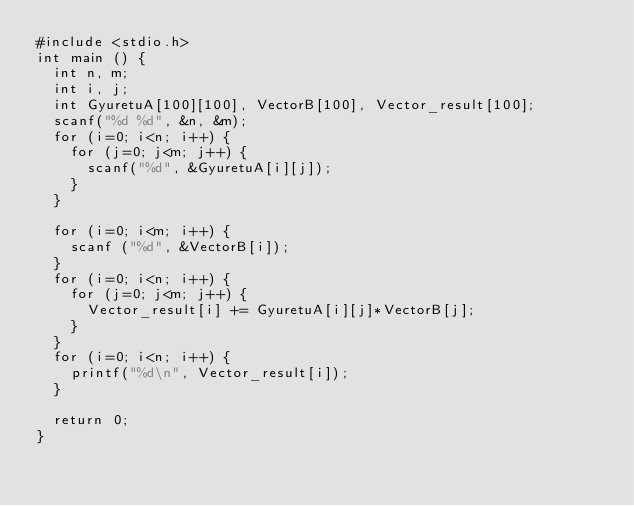<code> <loc_0><loc_0><loc_500><loc_500><_C_>#include <stdio.h>
int main () {
  int n, m;
  int i, j;
  int GyuretuA[100][100], VectorB[100], Vector_result[100];
  scanf("%d %d", &n, &m);
  for (i=0; i<n; i++) {
    for (j=0; j<m; j++) {
      scanf("%d", &GyuretuA[i][j]);
    }
  }

  for (i=0; i<m; i++) {
    scanf ("%d", &VectorB[i]);
  }
  for (i=0; i<n; i++) {
    for (j=0; j<m; j++) {
      Vector_result[i] += GyuretuA[i][j]*VectorB[j];
    }
  }
  for (i=0; i<n; i++) {
    printf("%d\n", Vector_result[i]);
  }

  return 0;
}</code> 